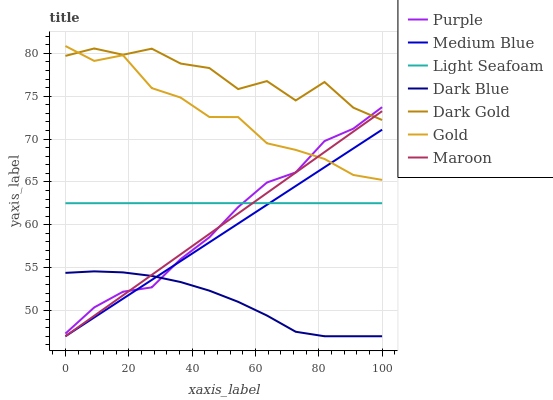Does Dark Blue have the minimum area under the curve?
Answer yes or no. Yes. Does Dark Gold have the maximum area under the curve?
Answer yes or no. Yes. Does Purple have the minimum area under the curve?
Answer yes or no. No. Does Purple have the maximum area under the curve?
Answer yes or no. No. Is Maroon the smoothest?
Answer yes or no. Yes. Is Dark Gold the roughest?
Answer yes or no. Yes. Is Purple the smoothest?
Answer yes or no. No. Is Purple the roughest?
Answer yes or no. No. Does Medium Blue have the lowest value?
Answer yes or no. Yes. Does Purple have the lowest value?
Answer yes or no. No. Does Gold have the highest value?
Answer yes or no. Yes. Does Dark Gold have the highest value?
Answer yes or no. No. Is Dark Blue less than Light Seafoam?
Answer yes or no. Yes. Is Dark Gold greater than Light Seafoam?
Answer yes or no. Yes. Does Gold intersect Dark Gold?
Answer yes or no. Yes. Is Gold less than Dark Gold?
Answer yes or no. No. Is Gold greater than Dark Gold?
Answer yes or no. No. Does Dark Blue intersect Light Seafoam?
Answer yes or no. No. 